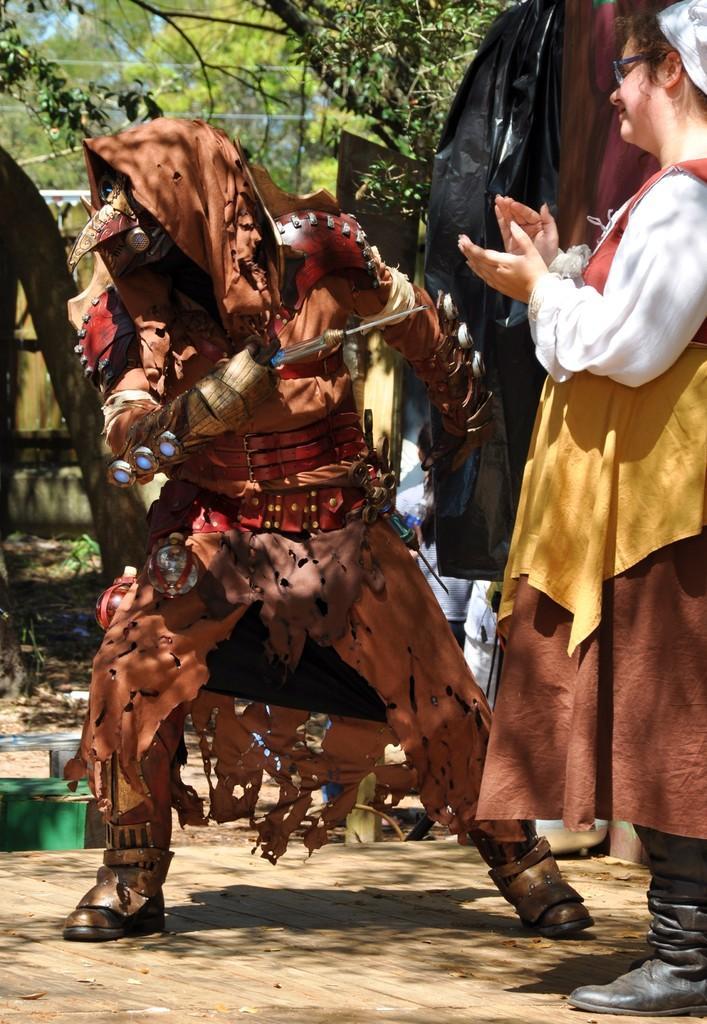Can you describe this image briefly? In the center of the image there is a person holding knife. To the right side of the image there is a lady clapping hands. In the background of the image there are trees. 